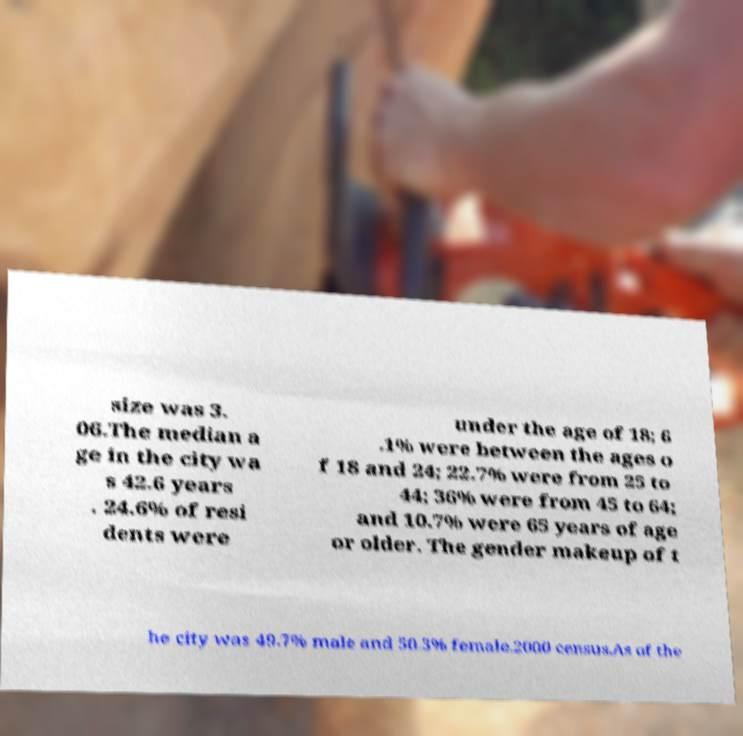What messages or text are displayed in this image? I need them in a readable, typed format. size was 3. 06.The median a ge in the city wa s 42.6 years . 24.6% of resi dents were under the age of 18; 6 .1% were between the ages o f 18 and 24; 22.7% were from 25 to 44; 36% were from 45 to 64; and 10.7% were 65 years of age or older. The gender makeup of t he city was 49.7% male and 50.3% female.2000 census.As of the 